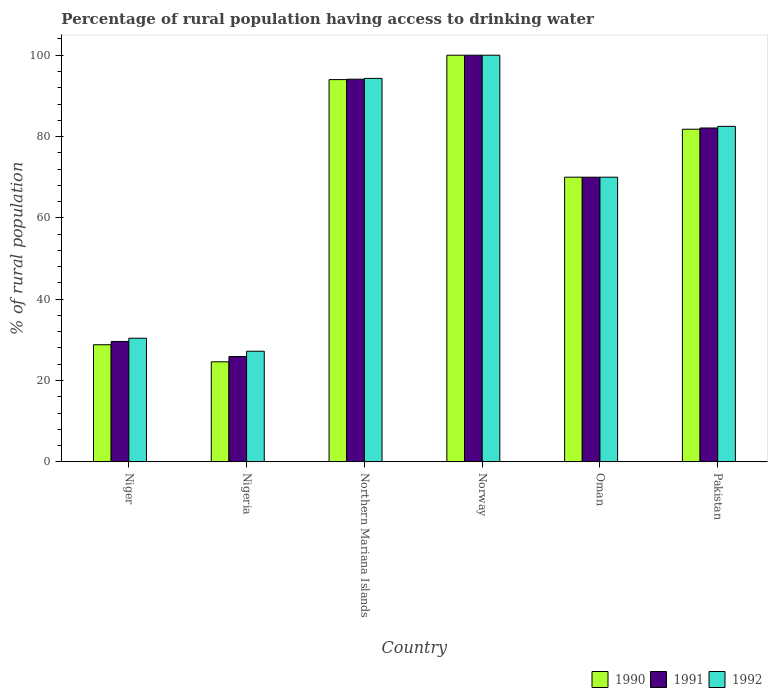How many different coloured bars are there?
Offer a very short reply. 3. Are the number of bars per tick equal to the number of legend labels?
Keep it short and to the point. Yes. Are the number of bars on each tick of the X-axis equal?
Keep it short and to the point. Yes. How many bars are there on the 3rd tick from the left?
Offer a terse response. 3. How many bars are there on the 4th tick from the right?
Ensure brevity in your answer.  3. What is the label of the 4th group of bars from the left?
Your answer should be compact. Norway. Across all countries, what is the maximum percentage of rural population having access to drinking water in 1990?
Provide a short and direct response. 100. Across all countries, what is the minimum percentage of rural population having access to drinking water in 1990?
Provide a succinct answer. 24.6. In which country was the percentage of rural population having access to drinking water in 1990 minimum?
Provide a succinct answer. Nigeria. What is the total percentage of rural population having access to drinking water in 1990 in the graph?
Ensure brevity in your answer.  399.2. What is the difference between the percentage of rural population having access to drinking water in 1991 in Nigeria and that in Oman?
Your answer should be very brief. -44.1. What is the difference between the percentage of rural population having access to drinking water in 1990 in Northern Mariana Islands and the percentage of rural population having access to drinking water in 1992 in Norway?
Your answer should be very brief. -6. What is the average percentage of rural population having access to drinking water in 1991 per country?
Offer a very short reply. 66.95. What is the ratio of the percentage of rural population having access to drinking water in 1990 in Nigeria to that in Northern Mariana Islands?
Your answer should be compact. 0.26. What is the difference between the highest and the second highest percentage of rural population having access to drinking water in 1992?
Keep it short and to the point. -17.5. What is the difference between the highest and the lowest percentage of rural population having access to drinking water in 1990?
Give a very brief answer. 75.4. How many bars are there?
Your response must be concise. 18. Are all the bars in the graph horizontal?
Your answer should be compact. No. What is the difference between two consecutive major ticks on the Y-axis?
Keep it short and to the point. 20. Are the values on the major ticks of Y-axis written in scientific E-notation?
Your answer should be very brief. No. Does the graph contain any zero values?
Offer a terse response. No. Does the graph contain grids?
Your answer should be compact. No. Where does the legend appear in the graph?
Provide a short and direct response. Bottom right. How are the legend labels stacked?
Make the answer very short. Horizontal. What is the title of the graph?
Your answer should be very brief. Percentage of rural population having access to drinking water. Does "1998" appear as one of the legend labels in the graph?
Your answer should be compact. No. What is the label or title of the Y-axis?
Provide a succinct answer. % of rural population. What is the % of rural population in 1990 in Niger?
Your answer should be very brief. 28.8. What is the % of rural population of 1991 in Niger?
Give a very brief answer. 29.6. What is the % of rural population of 1992 in Niger?
Keep it short and to the point. 30.4. What is the % of rural population of 1990 in Nigeria?
Make the answer very short. 24.6. What is the % of rural population of 1991 in Nigeria?
Make the answer very short. 25.9. What is the % of rural population in 1992 in Nigeria?
Your response must be concise. 27.2. What is the % of rural population of 1990 in Northern Mariana Islands?
Offer a terse response. 94. What is the % of rural population of 1991 in Northern Mariana Islands?
Provide a short and direct response. 94.1. What is the % of rural population in 1992 in Northern Mariana Islands?
Offer a terse response. 94.3. What is the % of rural population of 1990 in Norway?
Provide a succinct answer. 100. What is the % of rural population of 1990 in Oman?
Ensure brevity in your answer.  70. What is the % of rural population in 1991 in Oman?
Your answer should be compact. 70. What is the % of rural population in 1990 in Pakistan?
Offer a very short reply. 81.8. What is the % of rural population of 1991 in Pakistan?
Make the answer very short. 82.1. What is the % of rural population in 1992 in Pakistan?
Your response must be concise. 82.5. Across all countries, what is the maximum % of rural population in 1990?
Give a very brief answer. 100. Across all countries, what is the maximum % of rural population of 1991?
Give a very brief answer. 100. Across all countries, what is the maximum % of rural population in 1992?
Keep it short and to the point. 100. Across all countries, what is the minimum % of rural population of 1990?
Give a very brief answer. 24.6. Across all countries, what is the minimum % of rural population of 1991?
Provide a short and direct response. 25.9. Across all countries, what is the minimum % of rural population in 1992?
Offer a very short reply. 27.2. What is the total % of rural population of 1990 in the graph?
Make the answer very short. 399.2. What is the total % of rural population in 1991 in the graph?
Keep it short and to the point. 401.7. What is the total % of rural population of 1992 in the graph?
Offer a very short reply. 404.4. What is the difference between the % of rural population of 1990 in Niger and that in Nigeria?
Your answer should be very brief. 4.2. What is the difference between the % of rural population of 1990 in Niger and that in Northern Mariana Islands?
Keep it short and to the point. -65.2. What is the difference between the % of rural population of 1991 in Niger and that in Northern Mariana Islands?
Keep it short and to the point. -64.5. What is the difference between the % of rural population of 1992 in Niger and that in Northern Mariana Islands?
Make the answer very short. -63.9. What is the difference between the % of rural population in 1990 in Niger and that in Norway?
Make the answer very short. -71.2. What is the difference between the % of rural population in 1991 in Niger and that in Norway?
Ensure brevity in your answer.  -70.4. What is the difference between the % of rural population in 1992 in Niger and that in Norway?
Offer a terse response. -69.6. What is the difference between the % of rural population of 1990 in Niger and that in Oman?
Offer a terse response. -41.2. What is the difference between the % of rural population of 1991 in Niger and that in Oman?
Provide a short and direct response. -40.4. What is the difference between the % of rural population in 1992 in Niger and that in Oman?
Make the answer very short. -39.6. What is the difference between the % of rural population in 1990 in Niger and that in Pakistan?
Offer a very short reply. -53. What is the difference between the % of rural population of 1991 in Niger and that in Pakistan?
Your response must be concise. -52.5. What is the difference between the % of rural population of 1992 in Niger and that in Pakistan?
Your answer should be compact. -52.1. What is the difference between the % of rural population in 1990 in Nigeria and that in Northern Mariana Islands?
Make the answer very short. -69.4. What is the difference between the % of rural population of 1991 in Nigeria and that in Northern Mariana Islands?
Ensure brevity in your answer.  -68.2. What is the difference between the % of rural population in 1992 in Nigeria and that in Northern Mariana Islands?
Offer a terse response. -67.1. What is the difference between the % of rural population of 1990 in Nigeria and that in Norway?
Ensure brevity in your answer.  -75.4. What is the difference between the % of rural population of 1991 in Nigeria and that in Norway?
Your response must be concise. -74.1. What is the difference between the % of rural population of 1992 in Nigeria and that in Norway?
Provide a short and direct response. -72.8. What is the difference between the % of rural population in 1990 in Nigeria and that in Oman?
Your answer should be very brief. -45.4. What is the difference between the % of rural population in 1991 in Nigeria and that in Oman?
Provide a succinct answer. -44.1. What is the difference between the % of rural population in 1992 in Nigeria and that in Oman?
Provide a short and direct response. -42.8. What is the difference between the % of rural population of 1990 in Nigeria and that in Pakistan?
Your answer should be compact. -57.2. What is the difference between the % of rural population in 1991 in Nigeria and that in Pakistan?
Provide a short and direct response. -56.2. What is the difference between the % of rural population of 1992 in Nigeria and that in Pakistan?
Make the answer very short. -55.3. What is the difference between the % of rural population in 1990 in Northern Mariana Islands and that in Norway?
Give a very brief answer. -6. What is the difference between the % of rural population in 1991 in Northern Mariana Islands and that in Norway?
Provide a succinct answer. -5.9. What is the difference between the % of rural population in 1992 in Northern Mariana Islands and that in Norway?
Offer a terse response. -5.7. What is the difference between the % of rural population of 1990 in Northern Mariana Islands and that in Oman?
Provide a short and direct response. 24. What is the difference between the % of rural population of 1991 in Northern Mariana Islands and that in Oman?
Give a very brief answer. 24.1. What is the difference between the % of rural population of 1992 in Northern Mariana Islands and that in Oman?
Offer a terse response. 24.3. What is the difference between the % of rural population of 1991 in Norway and that in Oman?
Offer a terse response. 30. What is the difference between the % of rural population in 1992 in Norway and that in Oman?
Offer a very short reply. 30. What is the difference between the % of rural population in 1990 in Norway and that in Pakistan?
Offer a terse response. 18.2. What is the difference between the % of rural population in 1991 in Norway and that in Pakistan?
Make the answer very short. 17.9. What is the difference between the % of rural population of 1992 in Norway and that in Pakistan?
Give a very brief answer. 17.5. What is the difference between the % of rural population of 1990 in Oman and that in Pakistan?
Offer a very short reply. -11.8. What is the difference between the % of rural population in 1990 in Niger and the % of rural population in 1991 in Nigeria?
Provide a short and direct response. 2.9. What is the difference between the % of rural population in 1990 in Niger and the % of rural population in 1991 in Northern Mariana Islands?
Your answer should be compact. -65.3. What is the difference between the % of rural population in 1990 in Niger and the % of rural population in 1992 in Northern Mariana Islands?
Ensure brevity in your answer.  -65.5. What is the difference between the % of rural population of 1991 in Niger and the % of rural population of 1992 in Northern Mariana Islands?
Your answer should be compact. -64.7. What is the difference between the % of rural population of 1990 in Niger and the % of rural population of 1991 in Norway?
Your answer should be compact. -71.2. What is the difference between the % of rural population in 1990 in Niger and the % of rural population in 1992 in Norway?
Keep it short and to the point. -71.2. What is the difference between the % of rural population in 1991 in Niger and the % of rural population in 1992 in Norway?
Make the answer very short. -70.4. What is the difference between the % of rural population of 1990 in Niger and the % of rural population of 1991 in Oman?
Keep it short and to the point. -41.2. What is the difference between the % of rural population in 1990 in Niger and the % of rural population in 1992 in Oman?
Provide a short and direct response. -41.2. What is the difference between the % of rural population in 1991 in Niger and the % of rural population in 1992 in Oman?
Your response must be concise. -40.4. What is the difference between the % of rural population in 1990 in Niger and the % of rural population in 1991 in Pakistan?
Provide a short and direct response. -53.3. What is the difference between the % of rural population of 1990 in Niger and the % of rural population of 1992 in Pakistan?
Keep it short and to the point. -53.7. What is the difference between the % of rural population of 1991 in Niger and the % of rural population of 1992 in Pakistan?
Your response must be concise. -52.9. What is the difference between the % of rural population in 1990 in Nigeria and the % of rural population in 1991 in Northern Mariana Islands?
Keep it short and to the point. -69.5. What is the difference between the % of rural population of 1990 in Nigeria and the % of rural population of 1992 in Northern Mariana Islands?
Your answer should be compact. -69.7. What is the difference between the % of rural population of 1991 in Nigeria and the % of rural population of 1992 in Northern Mariana Islands?
Your answer should be very brief. -68.4. What is the difference between the % of rural population in 1990 in Nigeria and the % of rural population in 1991 in Norway?
Provide a succinct answer. -75.4. What is the difference between the % of rural population of 1990 in Nigeria and the % of rural population of 1992 in Norway?
Offer a terse response. -75.4. What is the difference between the % of rural population in 1991 in Nigeria and the % of rural population in 1992 in Norway?
Keep it short and to the point. -74.1. What is the difference between the % of rural population of 1990 in Nigeria and the % of rural population of 1991 in Oman?
Keep it short and to the point. -45.4. What is the difference between the % of rural population in 1990 in Nigeria and the % of rural population in 1992 in Oman?
Make the answer very short. -45.4. What is the difference between the % of rural population in 1991 in Nigeria and the % of rural population in 1992 in Oman?
Make the answer very short. -44.1. What is the difference between the % of rural population of 1990 in Nigeria and the % of rural population of 1991 in Pakistan?
Offer a terse response. -57.5. What is the difference between the % of rural population in 1990 in Nigeria and the % of rural population in 1992 in Pakistan?
Keep it short and to the point. -57.9. What is the difference between the % of rural population in 1991 in Nigeria and the % of rural population in 1992 in Pakistan?
Provide a succinct answer. -56.6. What is the difference between the % of rural population in 1990 in Northern Mariana Islands and the % of rural population in 1992 in Norway?
Provide a succinct answer. -6. What is the difference between the % of rural population in 1991 in Northern Mariana Islands and the % of rural population in 1992 in Oman?
Offer a very short reply. 24.1. What is the difference between the % of rural population of 1990 in Northern Mariana Islands and the % of rural population of 1991 in Pakistan?
Make the answer very short. 11.9. What is the difference between the % of rural population of 1990 in Northern Mariana Islands and the % of rural population of 1992 in Pakistan?
Your response must be concise. 11.5. What is the difference between the % of rural population of 1991 in Northern Mariana Islands and the % of rural population of 1992 in Pakistan?
Offer a terse response. 11.6. What is the difference between the % of rural population in 1990 in Norway and the % of rural population in 1991 in Pakistan?
Your response must be concise. 17.9. What is the difference between the % of rural population of 1990 in Oman and the % of rural population of 1991 in Pakistan?
Provide a short and direct response. -12.1. What is the difference between the % of rural population of 1990 in Oman and the % of rural population of 1992 in Pakistan?
Your answer should be very brief. -12.5. What is the average % of rural population in 1990 per country?
Your answer should be very brief. 66.53. What is the average % of rural population in 1991 per country?
Make the answer very short. 66.95. What is the average % of rural population in 1992 per country?
Make the answer very short. 67.4. What is the difference between the % of rural population in 1991 and % of rural population in 1992 in Niger?
Your answer should be very brief. -0.8. What is the difference between the % of rural population of 1990 and % of rural population of 1991 in Nigeria?
Ensure brevity in your answer.  -1.3. What is the difference between the % of rural population in 1991 and % of rural population in 1992 in Nigeria?
Your response must be concise. -1.3. What is the difference between the % of rural population in 1990 and % of rural population in 1991 in Northern Mariana Islands?
Give a very brief answer. -0.1. What is the difference between the % of rural population in 1990 and % of rural population in 1992 in Northern Mariana Islands?
Offer a very short reply. -0.3. What is the difference between the % of rural population in 1990 and % of rural population in 1991 in Norway?
Keep it short and to the point. 0. What is the difference between the % of rural population of 1990 and % of rural population of 1992 in Oman?
Offer a very short reply. 0. What is the difference between the % of rural population in 1991 and % of rural population in 1992 in Oman?
Keep it short and to the point. 0. What is the ratio of the % of rural population in 1990 in Niger to that in Nigeria?
Your response must be concise. 1.17. What is the ratio of the % of rural population in 1992 in Niger to that in Nigeria?
Provide a succinct answer. 1.12. What is the ratio of the % of rural population in 1990 in Niger to that in Northern Mariana Islands?
Offer a terse response. 0.31. What is the ratio of the % of rural population of 1991 in Niger to that in Northern Mariana Islands?
Make the answer very short. 0.31. What is the ratio of the % of rural population in 1992 in Niger to that in Northern Mariana Islands?
Make the answer very short. 0.32. What is the ratio of the % of rural population in 1990 in Niger to that in Norway?
Ensure brevity in your answer.  0.29. What is the ratio of the % of rural population in 1991 in Niger to that in Norway?
Keep it short and to the point. 0.3. What is the ratio of the % of rural population of 1992 in Niger to that in Norway?
Your response must be concise. 0.3. What is the ratio of the % of rural population in 1990 in Niger to that in Oman?
Make the answer very short. 0.41. What is the ratio of the % of rural population of 1991 in Niger to that in Oman?
Offer a very short reply. 0.42. What is the ratio of the % of rural population of 1992 in Niger to that in Oman?
Make the answer very short. 0.43. What is the ratio of the % of rural population of 1990 in Niger to that in Pakistan?
Your answer should be compact. 0.35. What is the ratio of the % of rural population of 1991 in Niger to that in Pakistan?
Your response must be concise. 0.36. What is the ratio of the % of rural population in 1992 in Niger to that in Pakistan?
Your response must be concise. 0.37. What is the ratio of the % of rural population of 1990 in Nigeria to that in Northern Mariana Islands?
Provide a short and direct response. 0.26. What is the ratio of the % of rural population of 1991 in Nigeria to that in Northern Mariana Islands?
Your answer should be very brief. 0.28. What is the ratio of the % of rural population of 1992 in Nigeria to that in Northern Mariana Islands?
Make the answer very short. 0.29. What is the ratio of the % of rural population of 1990 in Nigeria to that in Norway?
Offer a very short reply. 0.25. What is the ratio of the % of rural population in 1991 in Nigeria to that in Norway?
Give a very brief answer. 0.26. What is the ratio of the % of rural population in 1992 in Nigeria to that in Norway?
Your answer should be compact. 0.27. What is the ratio of the % of rural population in 1990 in Nigeria to that in Oman?
Your answer should be compact. 0.35. What is the ratio of the % of rural population in 1991 in Nigeria to that in Oman?
Offer a very short reply. 0.37. What is the ratio of the % of rural population in 1992 in Nigeria to that in Oman?
Offer a very short reply. 0.39. What is the ratio of the % of rural population in 1990 in Nigeria to that in Pakistan?
Offer a very short reply. 0.3. What is the ratio of the % of rural population of 1991 in Nigeria to that in Pakistan?
Keep it short and to the point. 0.32. What is the ratio of the % of rural population of 1992 in Nigeria to that in Pakistan?
Give a very brief answer. 0.33. What is the ratio of the % of rural population in 1990 in Northern Mariana Islands to that in Norway?
Give a very brief answer. 0.94. What is the ratio of the % of rural population of 1991 in Northern Mariana Islands to that in Norway?
Offer a very short reply. 0.94. What is the ratio of the % of rural population in 1992 in Northern Mariana Islands to that in Norway?
Provide a short and direct response. 0.94. What is the ratio of the % of rural population of 1990 in Northern Mariana Islands to that in Oman?
Your response must be concise. 1.34. What is the ratio of the % of rural population in 1991 in Northern Mariana Islands to that in Oman?
Provide a succinct answer. 1.34. What is the ratio of the % of rural population of 1992 in Northern Mariana Islands to that in Oman?
Ensure brevity in your answer.  1.35. What is the ratio of the % of rural population in 1990 in Northern Mariana Islands to that in Pakistan?
Give a very brief answer. 1.15. What is the ratio of the % of rural population in 1991 in Northern Mariana Islands to that in Pakistan?
Provide a short and direct response. 1.15. What is the ratio of the % of rural population of 1992 in Northern Mariana Islands to that in Pakistan?
Offer a very short reply. 1.14. What is the ratio of the % of rural population in 1990 in Norway to that in Oman?
Offer a very short reply. 1.43. What is the ratio of the % of rural population in 1991 in Norway to that in Oman?
Keep it short and to the point. 1.43. What is the ratio of the % of rural population in 1992 in Norway to that in Oman?
Your answer should be very brief. 1.43. What is the ratio of the % of rural population in 1990 in Norway to that in Pakistan?
Make the answer very short. 1.22. What is the ratio of the % of rural population in 1991 in Norway to that in Pakistan?
Your answer should be compact. 1.22. What is the ratio of the % of rural population in 1992 in Norway to that in Pakistan?
Your answer should be compact. 1.21. What is the ratio of the % of rural population of 1990 in Oman to that in Pakistan?
Provide a short and direct response. 0.86. What is the ratio of the % of rural population of 1991 in Oman to that in Pakistan?
Keep it short and to the point. 0.85. What is the ratio of the % of rural population of 1992 in Oman to that in Pakistan?
Provide a succinct answer. 0.85. What is the difference between the highest and the lowest % of rural population of 1990?
Your answer should be compact. 75.4. What is the difference between the highest and the lowest % of rural population in 1991?
Keep it short and to the point. 74.1. What is the difference between the highest and the lowest % of rural population of 1992?
Make the answer very short. 72.8. 